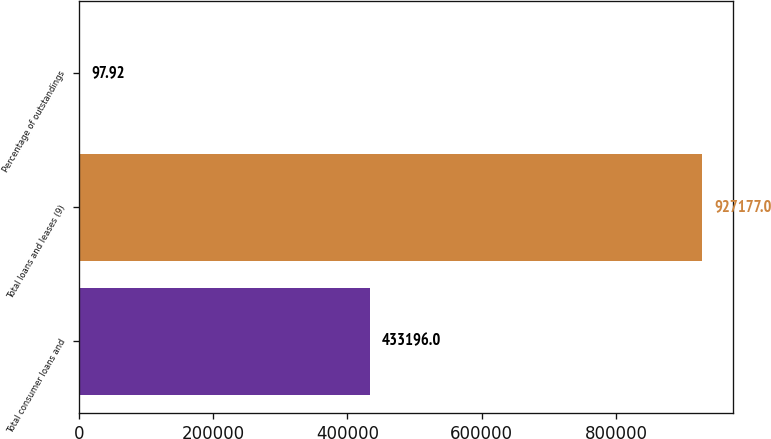<chart> <loc_0><loc_0><loc_500><loc_500><bar_chart><fcel>Total consumer loans and<fcel>Total loans and leases (9)<fcel>Percentage of outstandings<nl><fcel>433196<fcel>927177<fcel>97.92<nl></chart> 